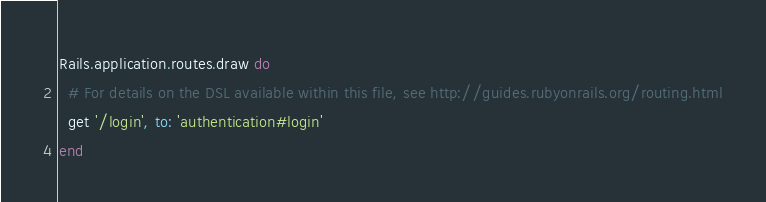<code> <loc_0><loc_0><loc_500><loc_500><_Ruby_>Rails.application.routes.draw do
  # For details on the DSL available within this file, see http://guides.rubyonrails.org/routing.html
  get '/login', to: 'authentication#login'
end
</code> 